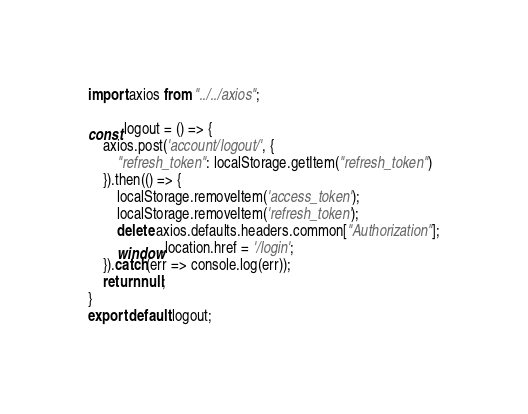Convert code to text. <code><loc_0><loc_0><loc_500><loc_500><_JavaScript_>import axios from "../../axios";

const logout = () => {
    axios.post('account/logout/', {
        "refresh_token": localStorage.getItem("refresh_token")
    }).then(() => {
        localStorage.removeItem('access_token');
        localStorage.removeItem('refresh_token');
        delete axios.defaults.headers.common["Authorization"];
        window.location.href = '/login';
    }).catch(err => console.log(err));
    return null;
}
export default logout;</code> 